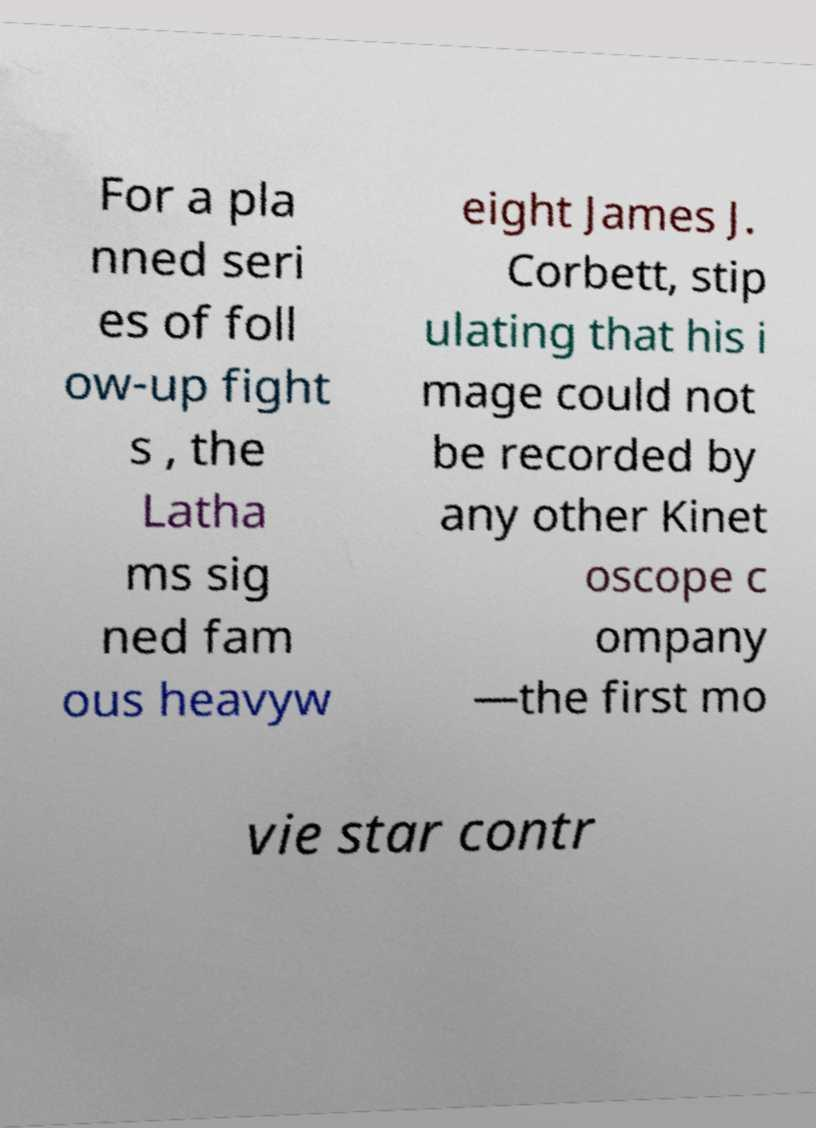What messages or text are displayed in this image? I need them in a readable, typed format. For a pla nned seri es of foll ow-up fight s , the Latha ms sig ned fam ous heavyw eight James J. Corbett, stip ulating that his i mage could not be recorded by any other Kinet oscope c ompany —the first mo vie star contr 